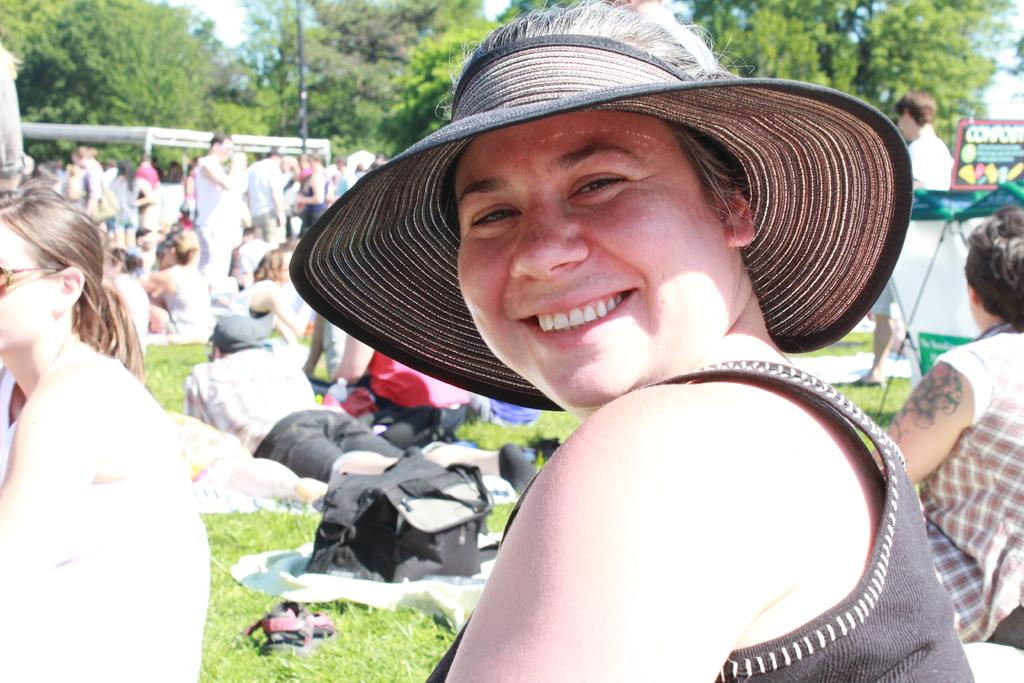Who or what can be seen in the image? There are people in the image. What type of natural environment is present in the image? There are trees and grass in the image. What is visible on the ground in the image? There are objects on the ground. What architectural features can be seen in the image? There is a pole and posts in the image. What part of the natural environment is visible in the image? The sky is visible in the image. What type of copper wire can be seen connecting the people in the image? There is no copper wire or any wire connecting the people in the image. 